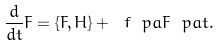Convert formula to latex. <formula><loc_0><loc_0><loc_500><loc_500>\frac { d } { d t } F = \{ F , H \} + \ f { \ p a F } { \ p a t } .</formula> 